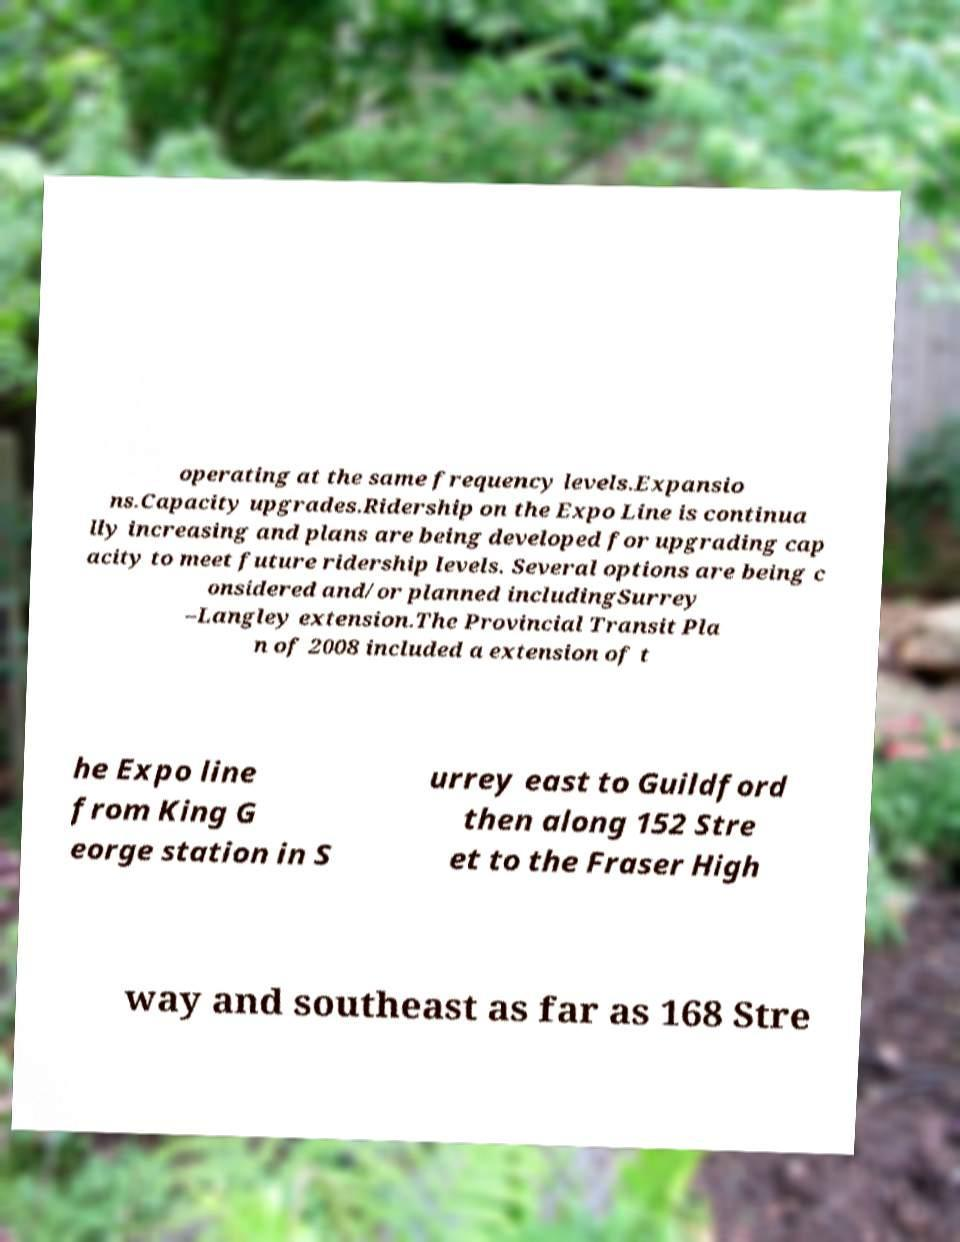Can you accurately transcribe the text from the provided image for me? operating at the same frequency levels.Expansio ns.Capacity upgrades.Ridership on the Expo Line is continua lly increasing and plans are being developed for upgrading cap acity to meet future ridership levels. Several options are being c onsidered and/or planned includingSurrey –Langley extension.The Provincial Transit Pla n of 2008 included a extension of t he Expo line from King G eorge station in S urrey east to Guildford then along 152 Stre et to the Fraser High way and southeast as far as 168 Stre 